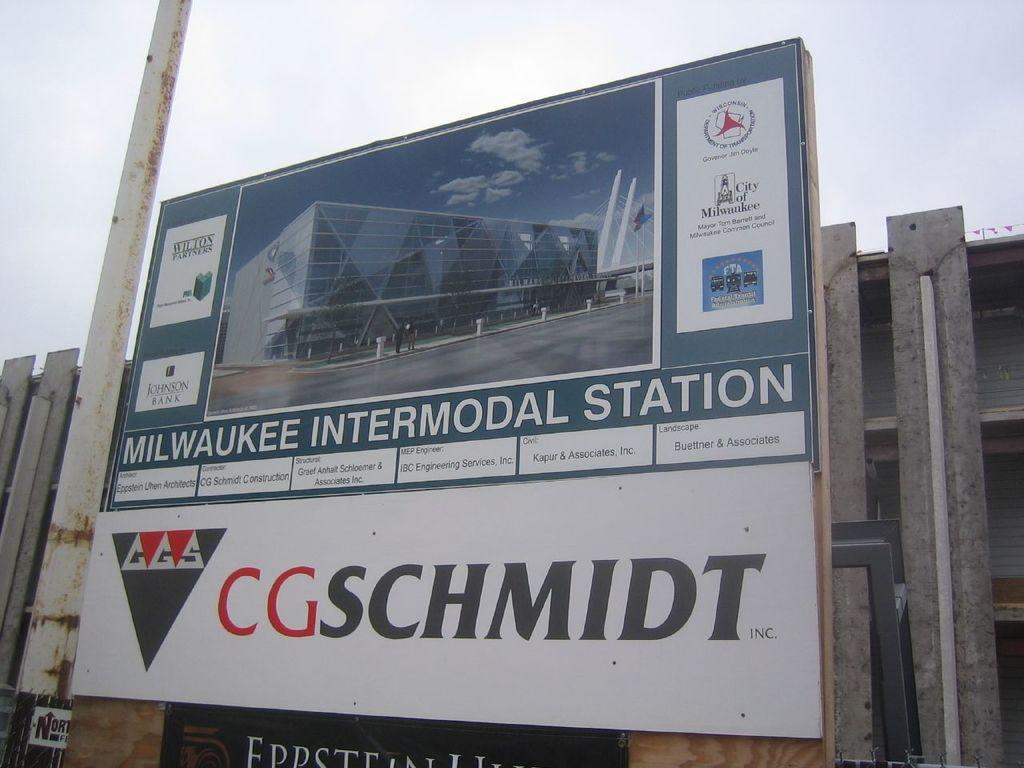Provide a one-sentence caption for the provided image. A sign for the Milwaukee Intermodal Station by CGSchmidt. 